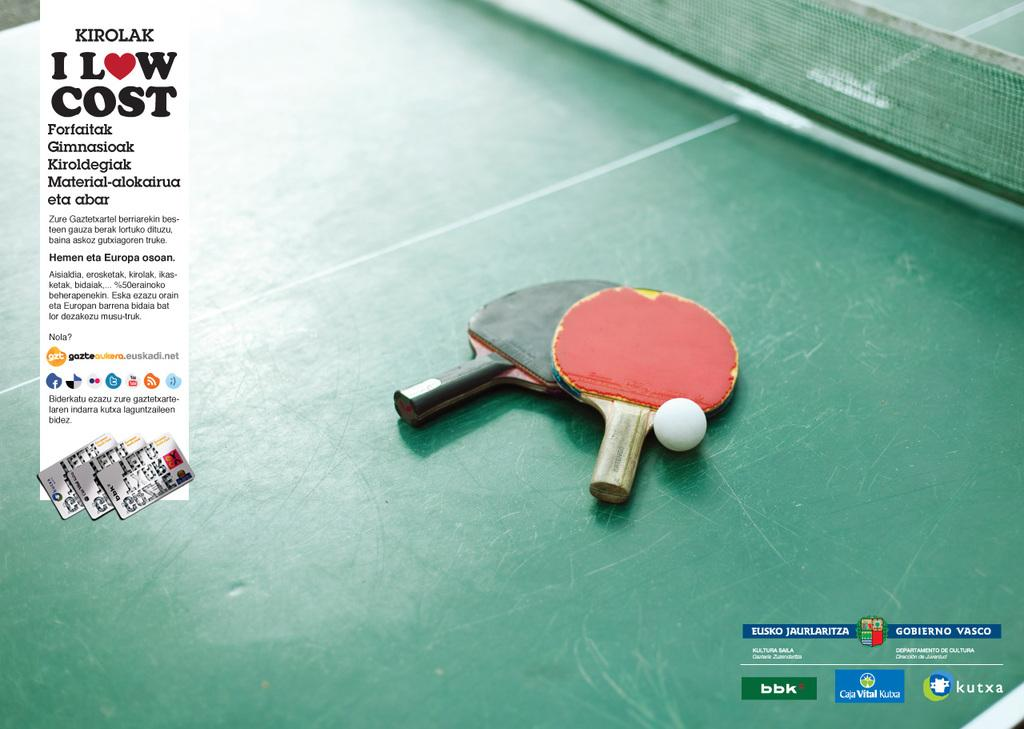What is the main subject of the advertisement in the image? The specific content of the advertisement is not mentioned, so we cannot determine the main subject. How many table tennis bats are visible in the image? There are two table tennis bats in the image. What is the third item related to table tennis in the image? There is a table tennis ball in the image. Where are the table tennis bats and ball placed in the image? The table tennis bats and ball are placed on a table tennis table. What news is being reported by the mind in the image? There is no mind or news reporting present in the image; it features an advertisement and table tennis equipment. 